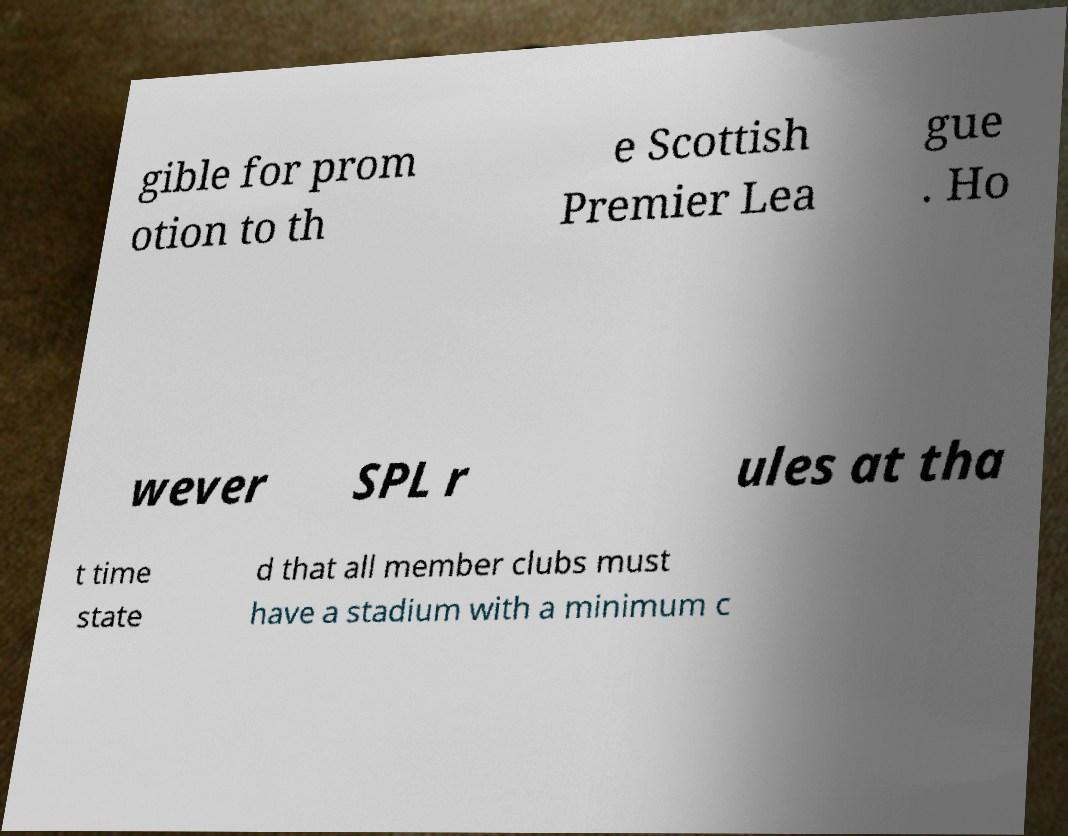Could you extract and type out the text from this image? gible for prom otion to th e Scottish Premier Lea gue . Ho wever SPL r ules at tha t time state d that all member clubs must have a stadium with a minimum c 